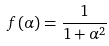<formula> <loc_0><loc_0><loc_500><loc_500>f ( \alpha ) = \frac { 1 } { 1 + \alpha ^ { 2 } }</formula> 